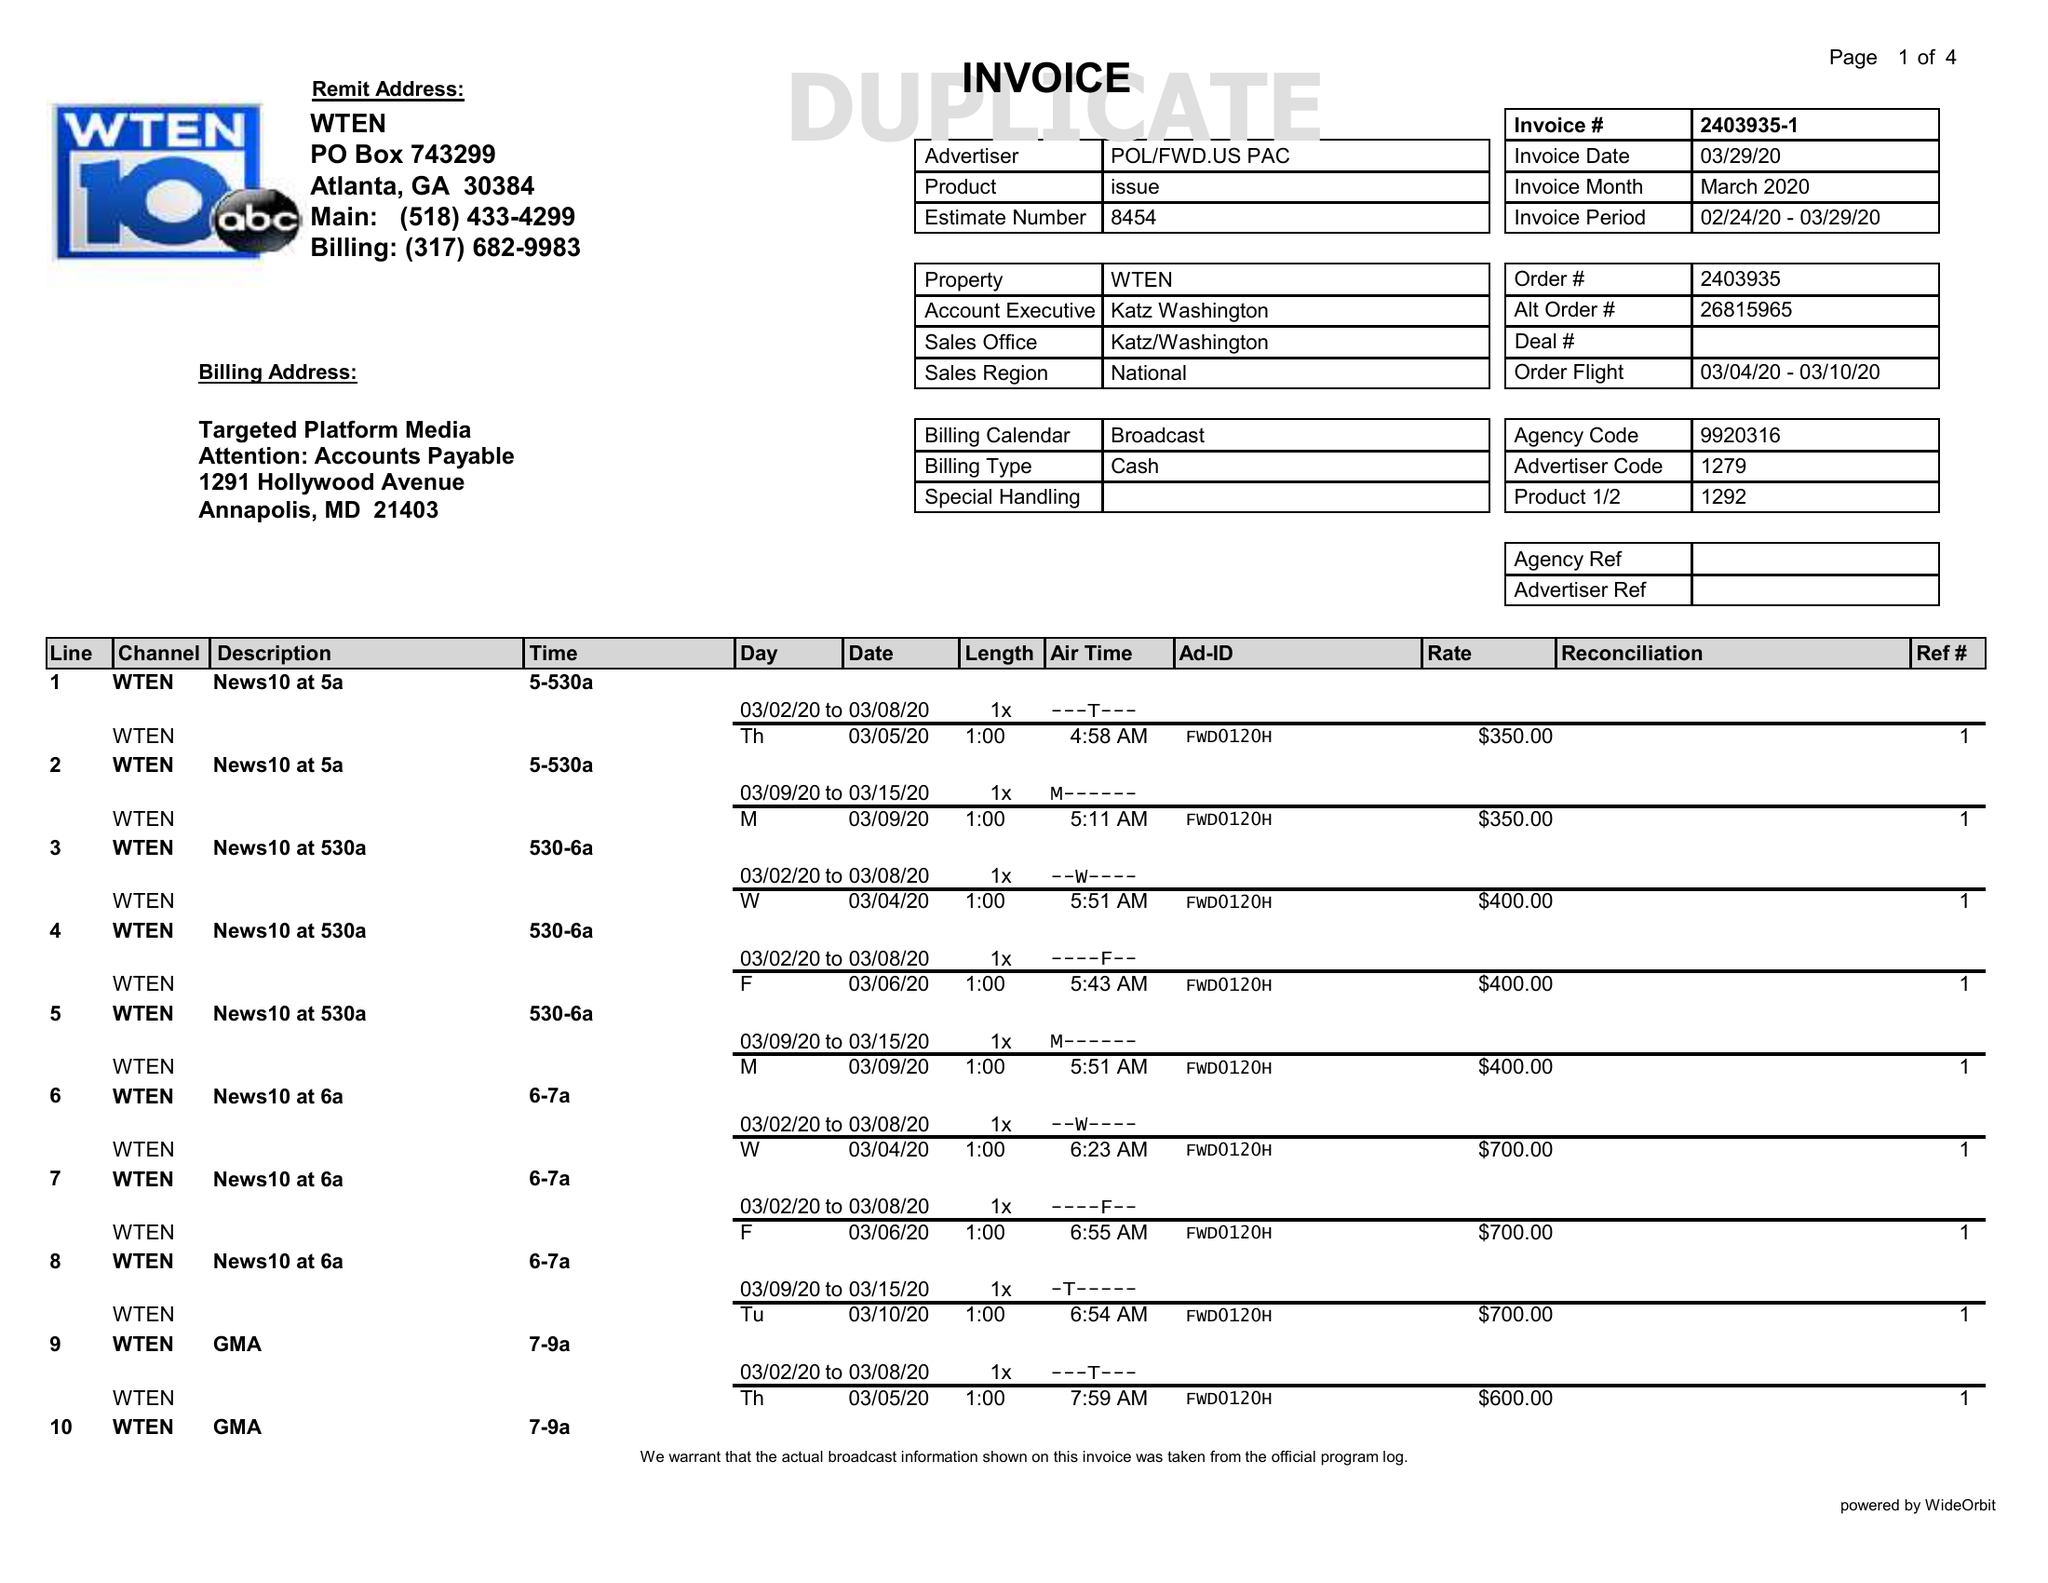What is the value for the flight_from?
Answer the question using a single word or phrase. 03/04/20 